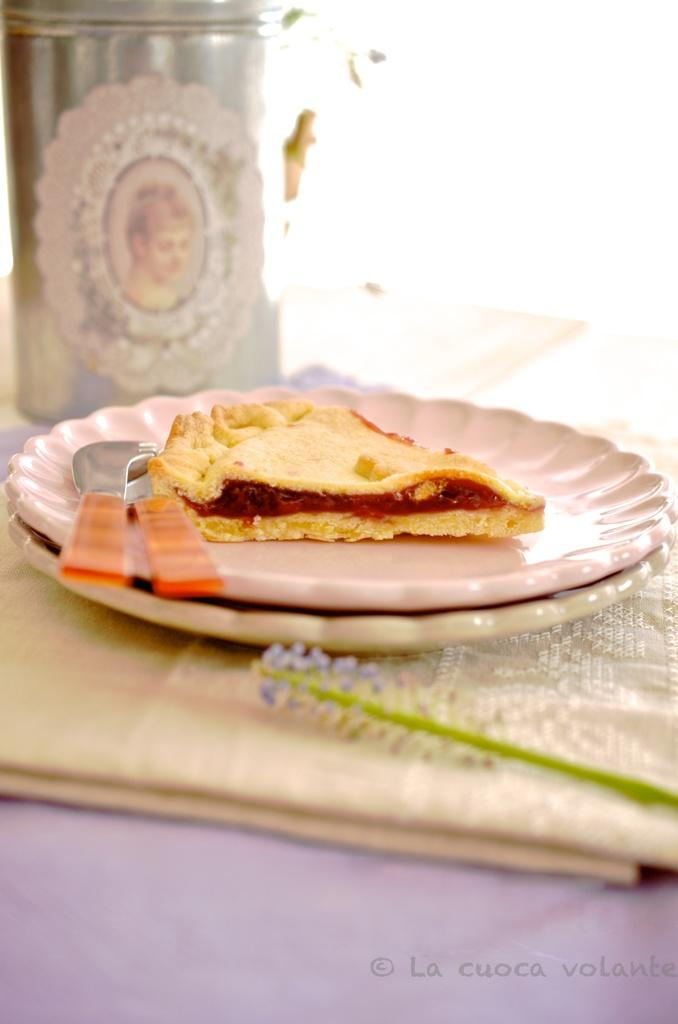What type of objects can be seen in the image? There are plates, food, spoons, knives, and a cloth in the image. What might be used for eating the food in the image? Spoons and knives can be used for eating the food in the image. What is covering the surface in the image? There is a cloth covering the surface in the image. Where are the objects located in the image? The objects are on a platform in the image. Is there any text present in the image? Yes, there is text in the bottom right side of the image. How many trees can be seen in the image? There are no trees present in the image. What type of stone is used to make the utensils in the image? There are no utensils made of stone in the image; the utensils are made of metal (knives) and plastic (spoons). 